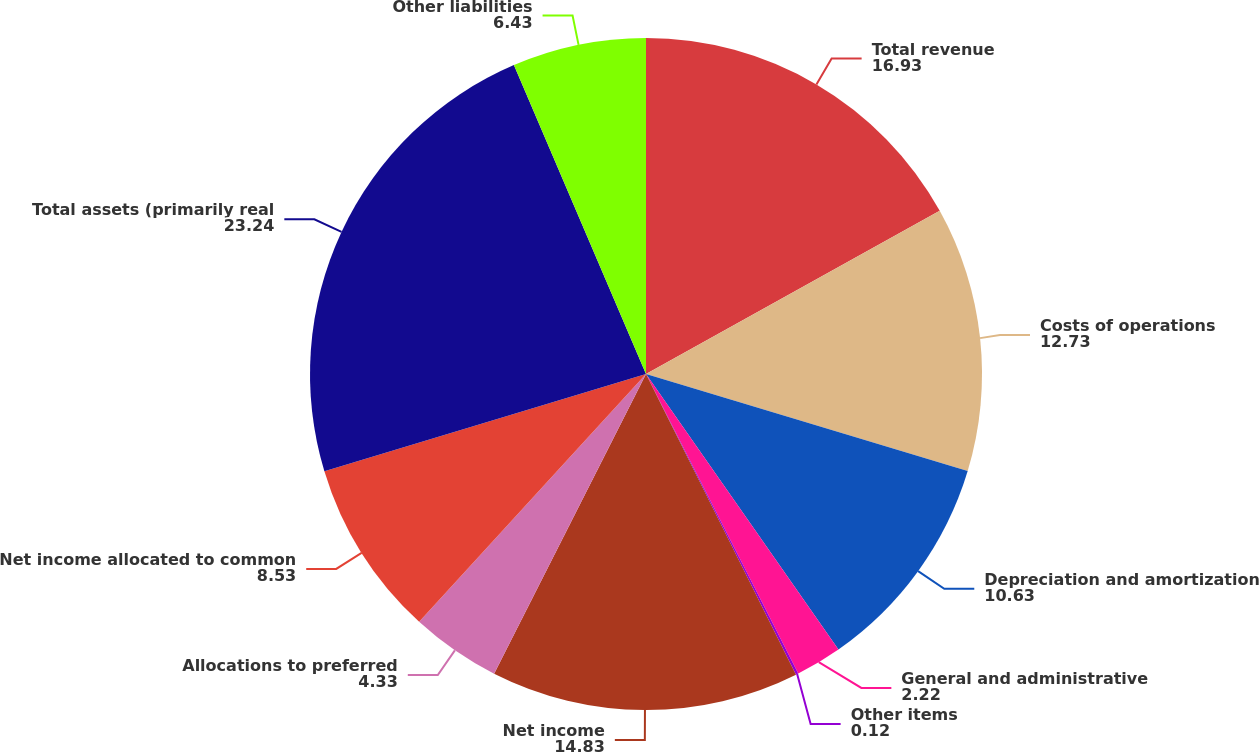<chart> <loc_0><loc_0><loc_500><loc_500><pie_chart><fcel>Total revenue<fcel>Costs of operations<fcel>Depreciation and amortization<fcel>General and administrative<fcel>Other items<fcel>Net income<fcel>Allocations to preferred<fcel>Net income allocated to common<fcel>Total assets (primarily real<fcel>Other liabilities<nl><fcel>16.93%<fcel>12.73%<fcel>10.63%<fcel>2.22%<fcel>0.12%<fcel>14.83%<fcel>4.33%<fcel>8.53%<fcel>23.24%<fcel>6.43%<nl></chart> 